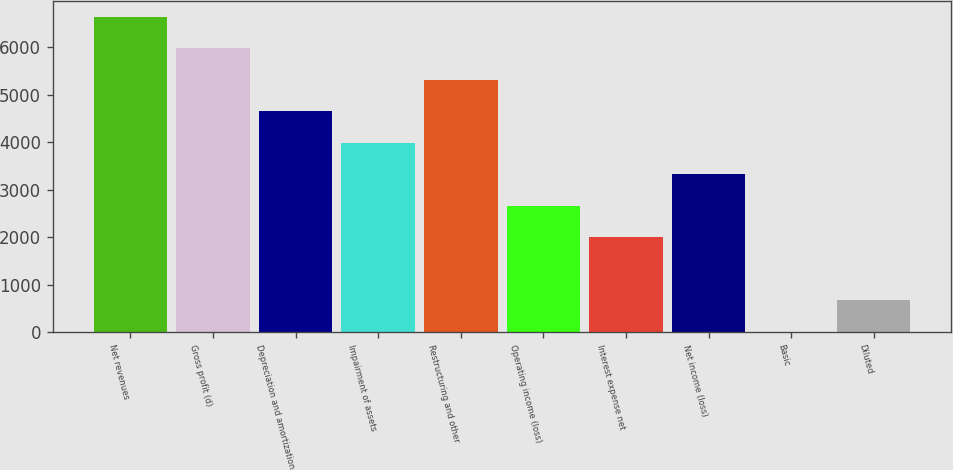Convert chart to OTSL. <chart><loc_0><loc_0><loc_500><loc_500><bar_chart><fcel>Net revenues<fcel>Gross profit (d)<fcel>Depreciation and amortization<fcel>Impairment of assets<fcel>Restructuring and other<fcel>Operating income (loss)<fcel>Interest expense net<fcel>Net income (loss)<fcel>Basic<fcel>Diluted<nl><fcel>6652.8<fcel>5987.64<fcel>4657.32<fcel>3992.16<fcel>5322.48<fcel>2661.84<fcel>1996.68<fcel>3327<fcel>1.2<fcel>666.36<nl></chart> 